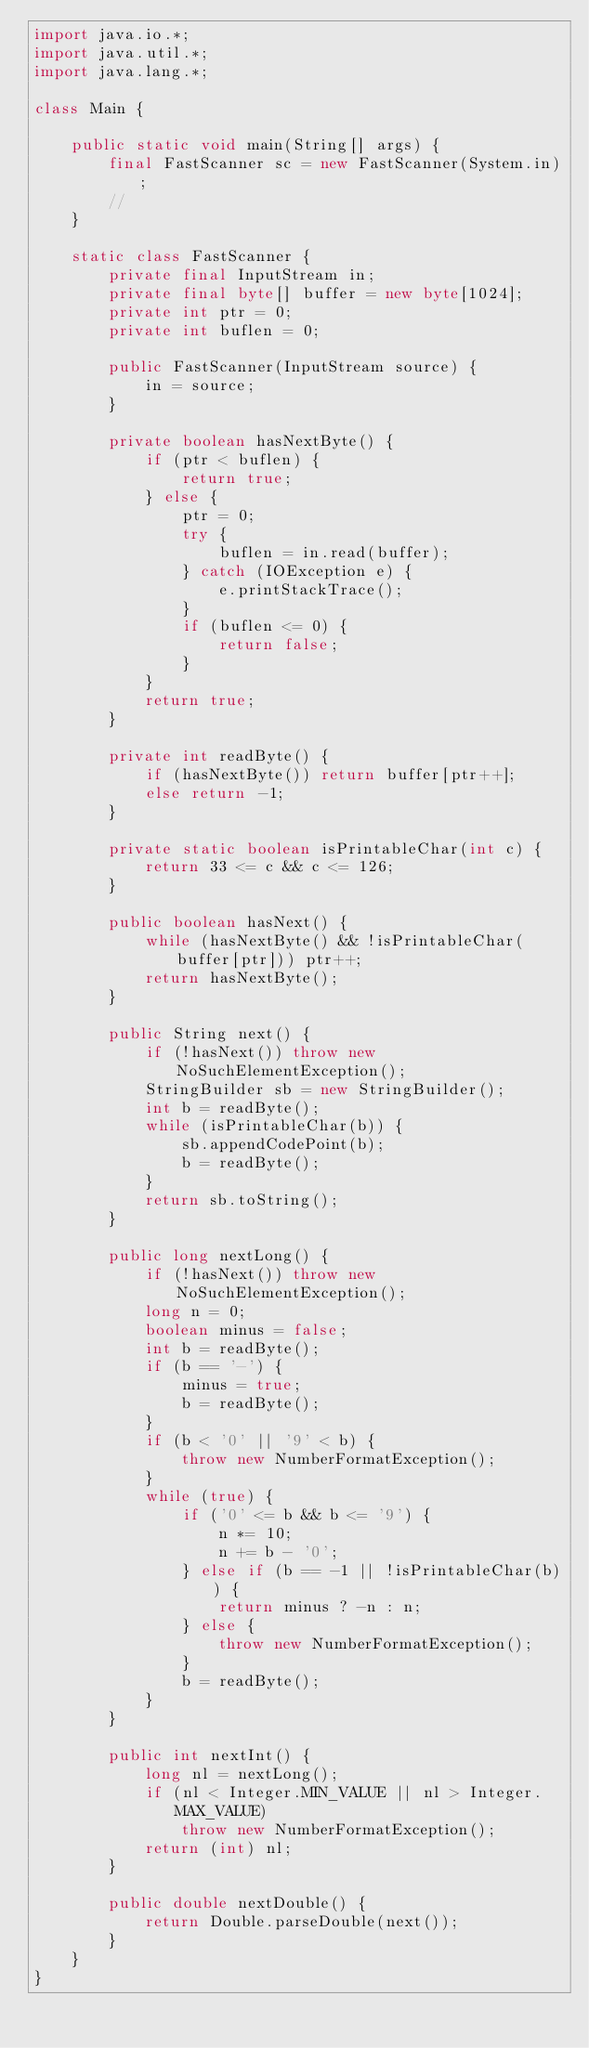<code> <loc_0><loc_0><loc_500><loc_500><_Java_>import java.io.*;
import java.util.*;
import java.lang.*;

class Main {

	public static void main(String[] args) {
		final FastScanner sc = new FastScanner(System.in);
		//
	}

	static class FastScanner {
		private final InputStream in;
		private final byte[] buffer = new byte[1024];
		private int ptr = 0;
		private int buflen = 0;

		public FastScanner(InputStream source) {
			in = source;
		}

		private boolean hasNextByte() {
			if (ptr < buflen) {
				return true;
			} else {
				ptr = 0;
				try {
					buflen = in.read(buffer);
				} catch (IOException e) {
					e.printStackTrace();
				}
				if (buflen <= 0) {
					return false;
				}
			}
			return true;
		}

		private int readByte() {
			if (hasNextByte()) return buffer[ptr++];
			else return -1;
		}

		private static boolean isPrintableChar(int c) {
			return 33 <= c && c <= 126;
		}

		public boolean hasNext() {
			while (hasNextByte() && !isPrintableChar(buffer[ptr])) ptr++;
			return hasNextByte();
		}

		public String next() {
			if (!hasNext()) throw new NoSuchElementException();
			StringBuilder sb = new StringBuilder();
			int b = readByte();
			while (isPrintableChar(b)) {
				sb.appendCodePoint(b);
				b = readByte();
			}
			return sb.toString();
		}

		public long nextLong() {
			if (!hasNext()) throw new NoSuchElementException();
			long n = 0;
			boolean minus = false;
			int b = readByte();
			if (b == '-') {
				minus = true;
				b = readByte();
			}
			if (b < '0' || '9' < b) {
				throw new NumberFormatException();
			}
			while (true) {
				if ('0' <= b && b <= '9') {
					n *= 10;
					n += b - '0';
				} else if (b == -1 || !isPrintableChar(b)) {
					return minus ? -n : n;
				} else {
					throw new NumberFormatException();
				}
				b = readByte();
			}
		}

		public int nextInt() {
			long nl = nextLong();
			if (nl < Integer.MIN_VALUE || nl > Integer.MAX_VALUE)
				throw new NumberFormatException();
			return (int) nl;
		}

		public double nextDouble() {
			return Double.parseDouble(next());
		}
	}
}
</code> 